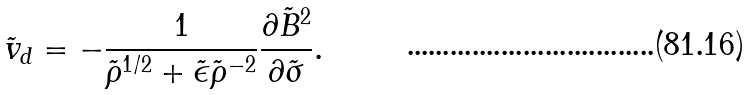<formula> <loc_0><loc_0><loc_500><loc_500>\tilde { v } _ { d } = - \frac { 1 } { \tilde { \rho } ^ { 1 / 2 } + \tilde { \epsilon } \tilde { \rho } ^ { - 2 } } \frac { \partial \tilde { B } ^ { 2 } } { \partial \tilde { \sigma } } .</formula> 